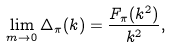<formula> <loc_0><loc_0><loc_500><loc_500>\lim _ { m \rightarrow 0 } \Delta _ { \pi } ( k ) = \frac { F _ { \pi } ( k ^ { 2 } ) } { k ^ { 2 } } ,</formula> 